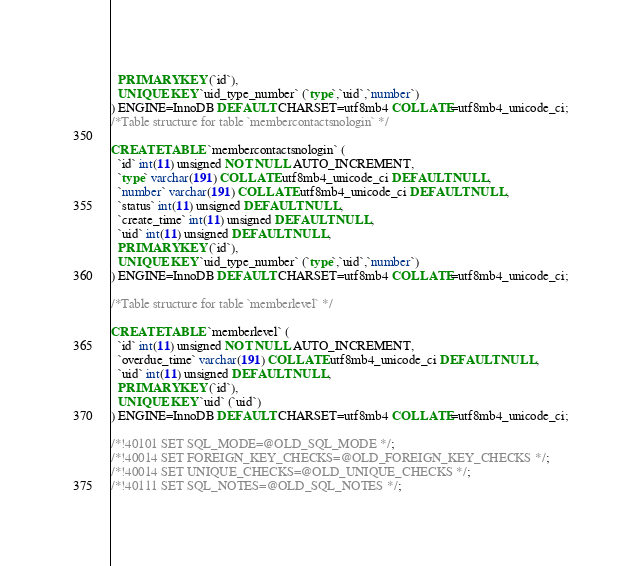<code> <loc_0><loc_0><loc_500><loc_500><_SQL_>  PRIMARY KEY (`id`),
  UNIQUE KEY `uid_type_number` (`type`,`uid`,`number`)
) ENGINE=InnoDB DEFAULT CHARSET=utf8mb4 COLLATE=utf8mb4_unicode_ci;
/*Table structure for table `membercontactsnologin` */

CREATE TABLE `membercontactsnologin` (
  `id` int(11) unsigned NOT NULL AUTO_INCREMENT,
  `type` varchar(191) COLLATE utf8mb4_unicode_ci DEFAULT NULL,
  `number` varchar(191) COLLATE utf8mb4_unicode_ci DEFAULT NULL,
  `status` int(11) unsigned DEFAULT NULL,
  `create_time` int(11) unsigned DEFAULT NULL,
  `uid` int(11) unsigned DEFAULT NULL,
  PRIMARY KEY (`id`),
  UNIQUE KEY `uid_type_number` (`type`,`uid`,`number`)
) ENGINE=InnoDB DEFAULT CHARSET=utf8mb4 COLLATE=utf8mb4_unicode_ci;

/*Table structure for table `memberlevel` */

CREATE TABLE `memberlevel` (
  `id` int(11) unsigned NOT NULL AUTO_INCREMENT,
  `overdue_time` varchar(191) COLLATE utf8mb4_unicode_ci DEFAULT NULL,
  `uid` int(11) unsigned DEFAULT NULL,
  PRIMARY KEY (`id`),
  UNIQUE KEY `uid` (`uid`)
) ENGINE=InnoDB DEFAULT CHARSET=utf8mb4 COLLATE=utf8mb4_unicode_ci;

/*!40101 SET SQL_MODE=@OLD_SQL_MODE */;
/*!40014 SET FOREIGN_KEY_CHECKS=@OLD_FOREIGN_KEY_CHECKS */;
/*!40014 SET UNIQUE_CHECKS=@OLD_UNIQUE_CHECKS */;
/*!40111 SET SQL_NOTES=@OLD_SQL_NOTES */;
</code> 